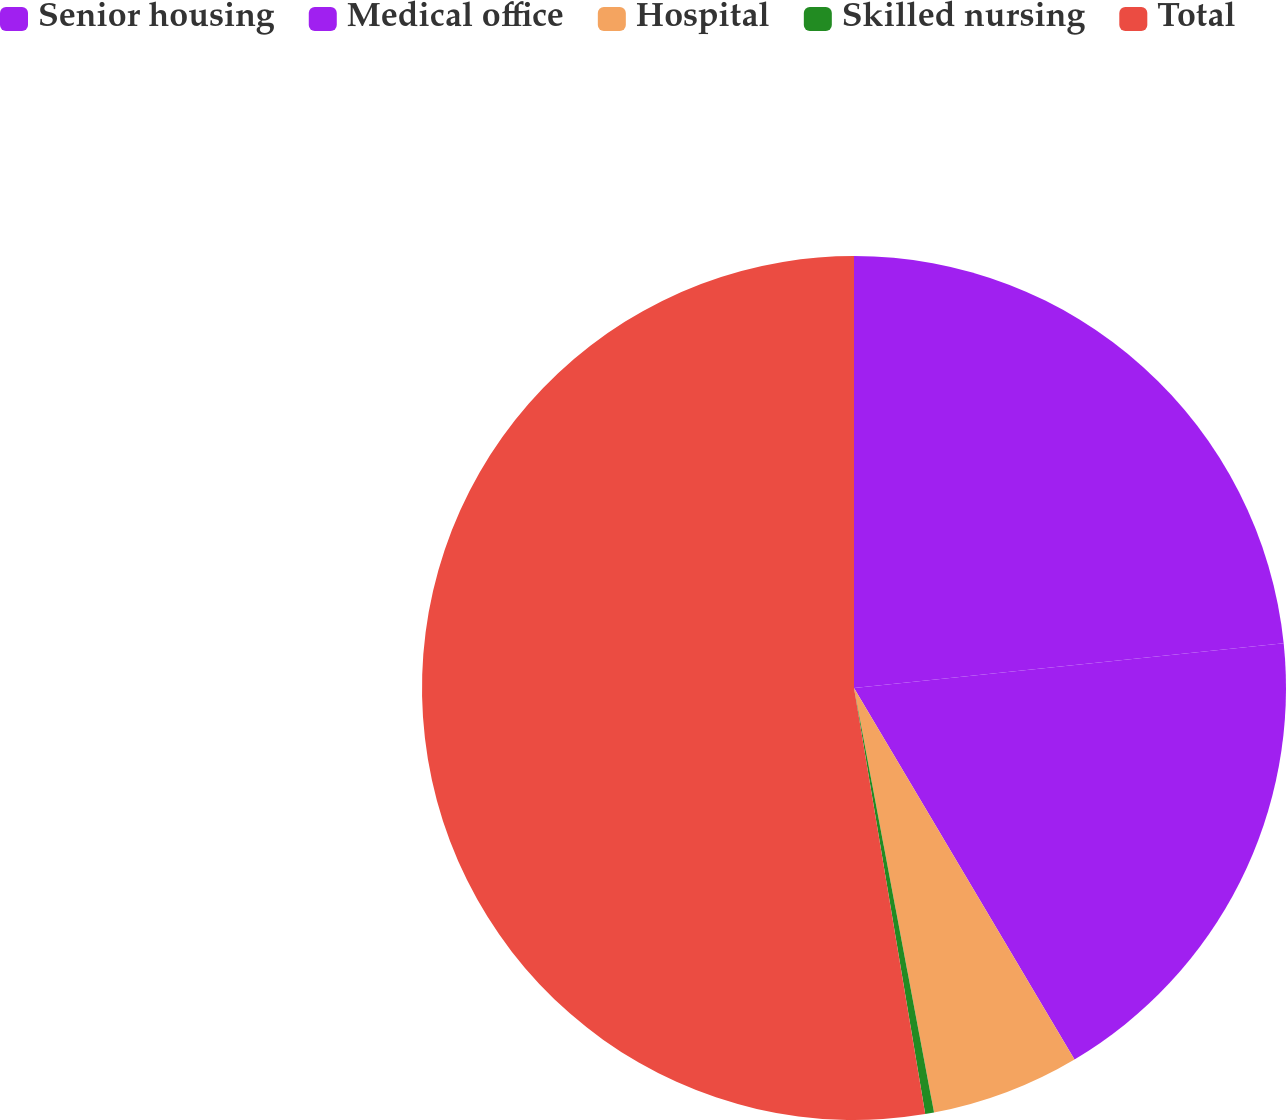Convert chart. <chart><loc_0><loc_0><loc_500><loc_500><pie_chart><fcel>Senior housing<fcel>Medical office<fcel>Hospital<fcel>Skilled nursing<fcel>Total<nl><fcel>23.35%<fcel>18.12%<fcel>5.56%<fcel>0.33%<fcel>52.63%<nl></chart> 